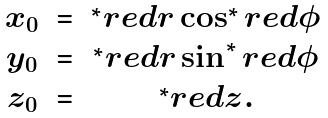Convert formula to latex. <formula><loc_0><loc_0><loc_500><loc_500>\begin{array} { c c c } x _ { 0 } & = & ^ { * } r e d { r } \cos ^ { * } r e d { \phi } \\ y _ { 0 } & = & ^ { * } r e d { r } \sin ^ { * } r e d { \phi } \\ z _ { 0 } & = & ^ { * } r e d { z } . \end{array}</formula> 